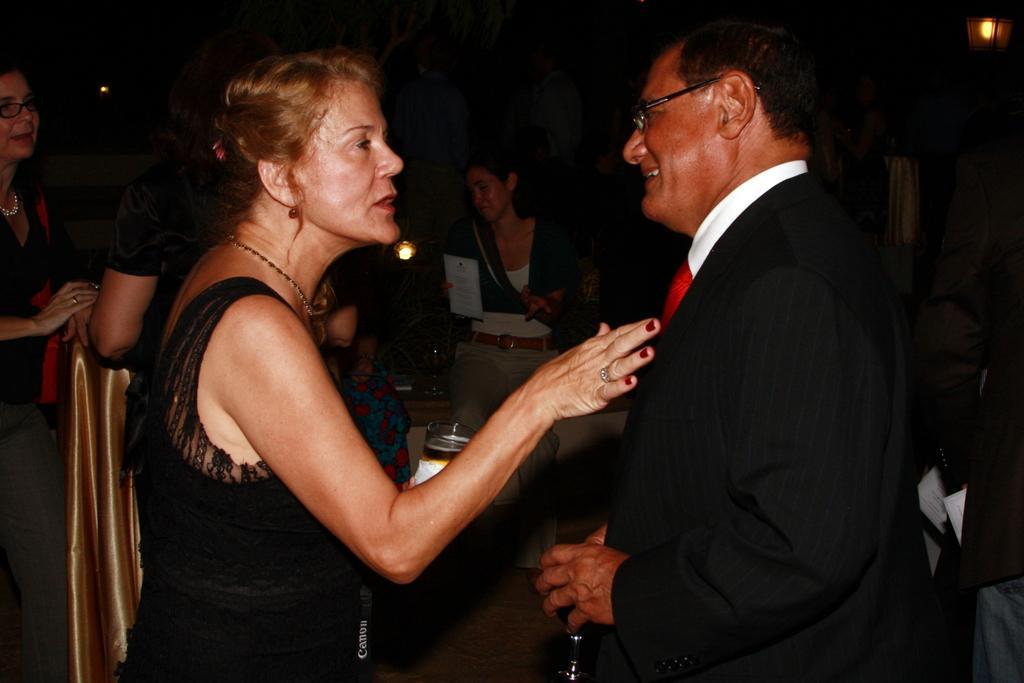How would you summarize this image in a sentence or two? In the foreground of the picture I can see two persons. I can see a man on the right side wearing a suit and tie. There is a smile on his face and he is holding a glass in his hands. There is a woman on the left side wearing black color clothes and looks like she is speaking. In the background, I can see a few persons. I can see a lamp on the top right side. 